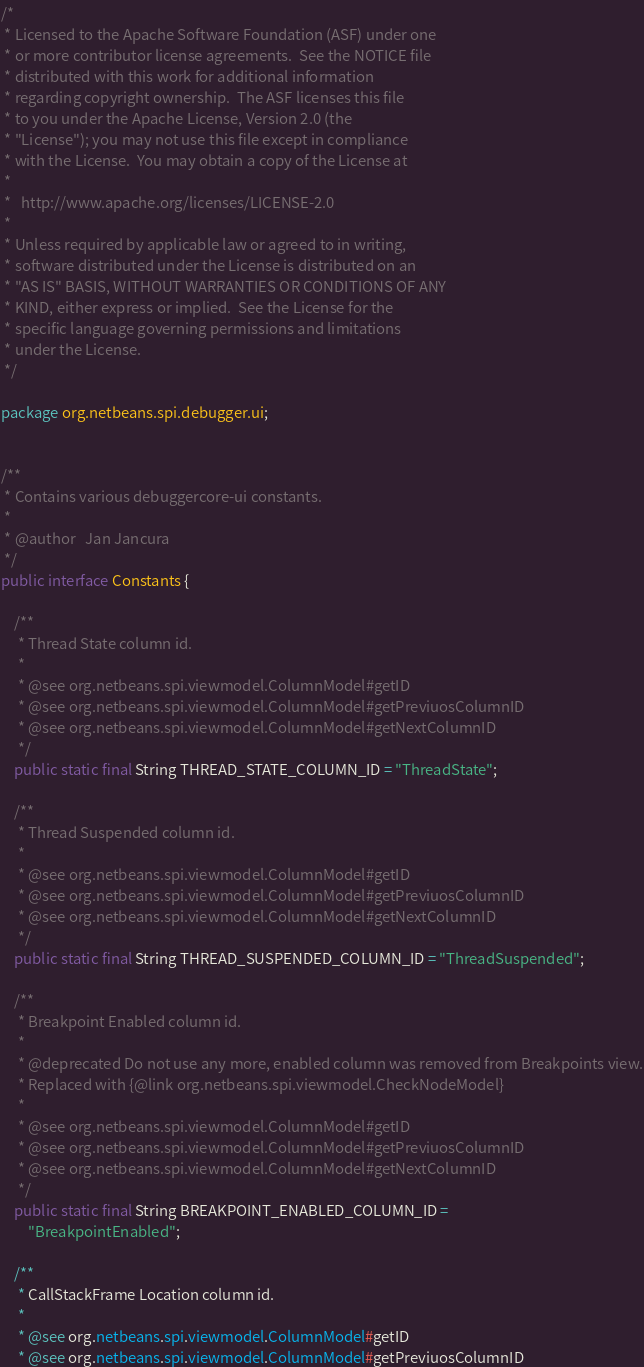Convert code to text. <code><loc_0><loc_0><loc_500><loc_500><_Java_>/*
 * Licensed to the Apache Software Foundation (ASF) under one
 * or more contributor license agreements.  See the NOTICE file
 * distributed with this work for additional information
 * regarding copyright ownership.  The ASF licenses this file
 * to you under the Apache License, Version 2.0 (the
 * "License"); you may not use this file except in compliance
 * with the License.  You may obtain a copy of the License at
 *
 *   http://www.apache.org/licenses/LICENSE-2.0
 *
 * Unless required by applicable law or agreed to in writing,
 * software distributed under the License is distributed on an
 * "AS IS" BASIS, WITHOUT WARRANTIES OR CONDITIONS OF ANY
 * KIND, either express or implied.  See the License for the
 * specific language governing permissions and limitations
 * under the License.
 */

package org.netbeans.spi.debugger.ui;


/**
 * Contains various debuggercore-ui constants.
 *
 * @author   Jan Jancura
 */
public interface Constants {

    /**
     * Thread State column id.
     *
     * @see org.netbeans.spi.viewmodel.ColumnModel#getID
     * @see org.netbeans.spi.viewmodel.ColumnModel#getPreviuosColumnID
     * @see org.netbeans.spi.viewmodel.ColumnModel#getNextColumnID
     */
    public static final String THREAD_STATE_COLUMN_ID = "ThreadState";

    /**
     * Thread Suspended column id.
     *
     * @see org.netbeans.spi.viewmodel.ColumnModel#getID
     * @see org.netbeans.spi.viewmodel.ColumnModel#getPreviuosColumnID
     * @see org.netbeans.spi.viewmodel.ColumnModel#getNextColumnID
     */
    public static final String THREAD_SUSPENDED_COLUMN_ID = "ThreadSuspended";

    /**
     * Breakpoint Enabled column id.
     *
     * @deprecated Do not use any more, enabled column was removed from Breakpoints view.
     * Replaced with {@link org.netbeans.spi.viewmodel.CheckNodeModel}
     *
     * @see org.netbeans.spi.viewmodel.ColumnModel#getID
     * @see org.netbeans.spi.viewmodel.ColumnModel#getPreviuosColumnID
     * @see org.netbeans.spi.viewmodel.ColumnModel#getNextColumnID
     */
    public static final String BREAKPOINT_ENABLED_COLUMN_ID = 
        "BreakpointEnabled";

    /**
     * CallStackFrame Location column id.
     *
     * @see org.netbeans.spi.viewmodel.ColumnModel#getID
     * @see org.netbeans.spi.viewmodel.ColumnModel#getPreviuosColumnID</code> 